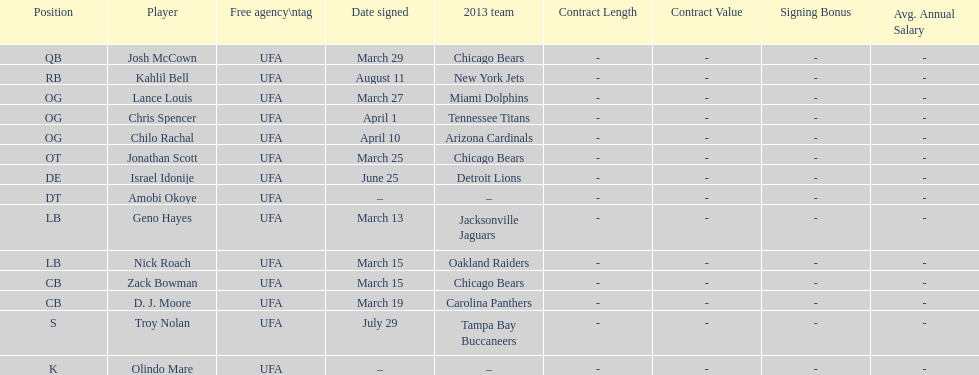How many players were signed in march? 7. 